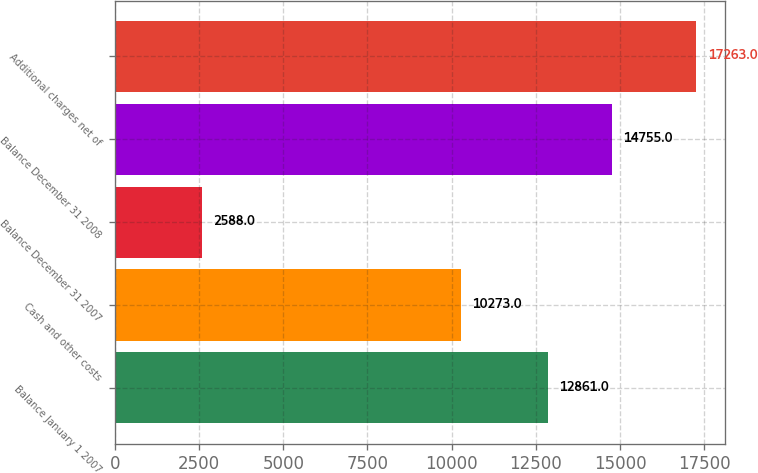<chart> <loc_0><loc_0><loc_500><loc_500><bar_chart><fcel>Balance January 1 2007<fcel>Cash and other costs<fcel>Balance December 31 2007<fcel>Balance December 31 2008<fcel>Additional charges net of<nl><fcel>12861<fcel>10273<fcel>2588<fcel>14755<fcel>17263<nl></chart> 